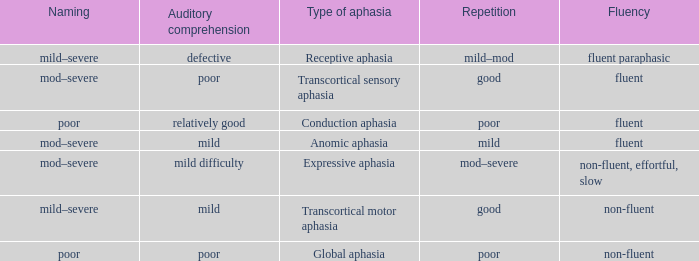Name the naming for fluent and poor comprehension Mod–severe. 